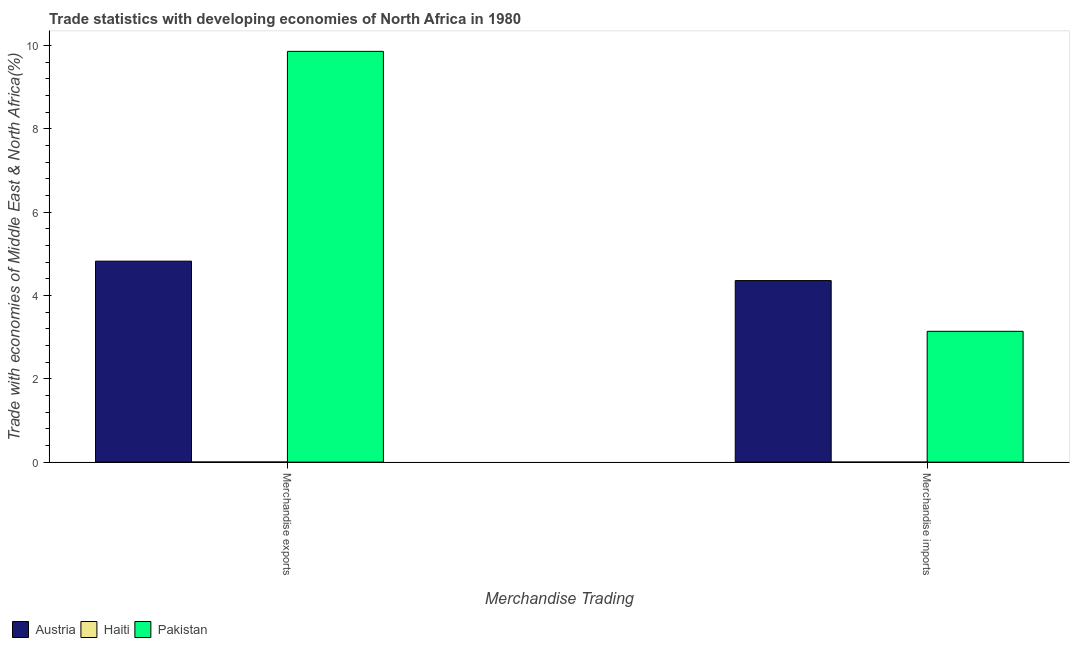Are the number of bars per tick equal to the number of legend labels?
Ensure brevity in your answer.  Yes. Are the number of bars on each tick of the X-axis equal?
Keep it short and to the point. Yes. How many bars are there on the 1st tick from the left?
Your response must be concise. 3. How many bars are there on the 1st tick from the right?
Your answer should be compact. 3. What is the merchandise imports in Austria?
Ensure brevity in your answer.  4.36. Across all countries, what is the maximum merchandise imports?
Offer a very short reply. 4.36. Across all countries, what is the minimum merchandise exports?
Your answer should be very brief. 0. In which country was the merchandise exports minimum?
Give a very brief answer. Haiti. What is the total merchandise imports in the graph?
Provide a short and direct response. 7.5. What is the difference between the merchandise imports in Pakistan and that in Haiti?
Offer a very short reply. 3.14. What is the difference between the merchandise imports in Austria and the merchandise exports in Haiti?
Make the answer very short. 4.36. What is the average merchandise imports per country?
Make the answer very short. 2.5. What is the difference between the merchandise exports and merchandise imports in Austria?
Your answer should be compact. 0.47. In how many countries, is the merchandise exports greater than 3.2 %?
Provide a succinct answer. 2. What is the ratio of the merchandise exports in Pakistan to that in Austria?
Your answer should be very brief. 2.04. In how many countries, is the merchandise exports greater than the average merchandise exports taken over all countries?
Ensure brevity in your answer.  1. What does the 2nd bar from the left in Merchandise imports represents?
Ensure brevity in your answer.  Haiti. Are the values on the major ticks of Y-axis written in scientific E-notation?
Provide a succinct answer. No. What is the title of the graph?
Offer a terse response. Trade statistics with developing economies of North Africa in 1980. What is the label or title of the X-axis?
Give a very brief answer. Merchandise Trading. What is the label or title of the Y-axis?
Provide a succinct answer. Trade with economies of Middle East & North Africa(%). What is the Trade with economies of Middle East & North Africa(%) of Austria in Merchandise exports?
Give a very brief answer. 4.83. What is the Trade with economies of Middle East & North Africa(%) of Haiti in Merchandise exports?
Offer a very short reply. 0. What is the Trade with economies of Middle East & North Africa(%) of Pakistan in Merchandise exports?
Offer a very short reply. 9.86. What is the Trade with economies of Middle East & North Africa(%) in Austria in Merchandise imports?
Make the answer very short. 4.36. What is the Trade with economies of Middle East & North Africa(%) in Haiti in Merchandise imports?
Give a very brief answer. 0. What is the Trade with economies of Middle East & North Africa(%) in Pakistan in Merchandise imports?
Offer a terse response. 3.14. Across all Merchandise Trading, what is the maximum Trade with economies of Middle East & North Africa(%) of Austria?
Provide a short and direct response. 4.83. Across all Merchandise Trading, what is the maximum Trade with economies of Middle East & North Africa(%) of Haiti?
Offer a very short reply. 0. Across all Merchandise Trading, what is the maximum Trade with economies of Middle East & North Africa(%) of Pakistan?
Your answer should be very brief. 9.86. Across all Merchandise Trading, what is the minimum Trade with economies of Middle East & North Africa(%) in Austria?
Your answer should be compact. 4.36. Across all Merchandise Trading, what is the minimum Trade with economies of Middle East & North Africa(%) in Haiti?
Your response must be concise. 0. Across all Merchandise Trading, what is the minimum Trade with economies of Middle East & North Africa(%) in Pakistan?
Offer a very short reply. 3.14. What is the total Trade with economies of Middle East & North Africa(%) in Austria in the graph?
Ensure brevity in your answer.  9.18. What is the total Trade with economies of Middle East & North Africa(%) of Haiti in the graph?
Keep it short and to the point. 0. What is the total Trade with economies of Middle East & North Africa(%) in Pakistan in the graph?
Make the answer very short. 13. What is the difference between the Trade with economies of Middle East & North Africa(%) in Austria in Merchandise exports and that in Merchandise imports?
Offer a terse response. 0.47. What is the difference between the Trade with economies of Middle East & North Africa(%) of Haiti in Merchandise exports and that in Merchandise imports?
Ensure brevity in your answer.  0. What is the difference between the Trade with economies of Middle East & North Africa(%) in Pakistan in Merchandise exports and that in Merchandise imports?
Ensure brevity in your answer.  6.72. What is the difference between the Trade with economies of Middle East & North Africa(%) of Austria in Merchandise exports and the Trade with economies of Middle East & North Africa(%) of Haiti in Merchandise imports?
Ensure brevity in your answer.  4.82. What is the difference between the Trade with economies of Middle East & North Africa(%) of Austria in Merchandise exports and the Trade with economies of Middle East & North Africa(%) of Pakistan in Merchandise imports?
Your answer should be compact. 1.69. What is the difference between the Trade with economies of Middle East & North Africa(%) in Haiti in Merchandise exports and the Trade with economies of Middle East & North Africa(%) in Pakistan in Merchandise imports?
Ensure brevity in your answer.  -3.14. What is the average Trade with economies of Middle East & North Africa(%) of Austria per Merchandise Trading?
Provide a succinct answer. 4.59. What is the average Trade with economies of Middle East & North Africa(%) in Haiti per Merchandise Trading?
Your response must be concise. 0. What is the average Trade with economies of Middle East & North Africa(%) of Pakistan per Merchandise Trading?
Your answer should be compact. 6.5. What is the difference between the Trade with economies of Middle East & North Africa(%) of Austria and Trade with economies of Middle East & North Africa(%) of Haiti in Merchandise exports?
Make the answer very short. 4.82. What is the difference between the Trade with economies of Middle East & North Africa(%) of Austria and Trade with economies of Middle East & North Africa(%) of Pakistan in Merchandise exports?
Provide a succinct answer. -5.04. What is the difference between the Trade with economies of Middle East & North Africa(%) in Haiti and Trade with economies of Middle East & North Africa(%) in Pakistan in Merchandise exports?
Provide a succinct answer. -9.86. What is the difference between the Trade with economies of Middle East & North Africa(%) of Austria and Trade with economies of Middle East & North Africa(%) of Haiti in Merchandise imports?
Offer a very short reply. 4.36. What is the difference between the Trade with economies of Middle East & North Africa(%) of Austria and Trade with economies of Middle East & North Africa(%) of Pakistan in Merchandise imports?
Ensure brevity in your answer.  1.22. What is the difference between the Trade with economies of Middle East & North Africa(%) of Haiti and Trade with economies of Middle East & North Africa(%) of Pakistan in Merchandise imports?
Make the answer very short. -3.14. What is the ratio of the Trade with economies of Middle East & North Africa(%) in Austria in Merchandise exports to that in Merchandise imports?
Provide a short and direct response. 1.11. What is the ratio of the Trade with economies of Middle East & North Africa(%) of Haiti in Merchandise exports to that in Merchandise imports?
Make the answer very short. 4.71. What is the ratio of the Trade with economies of Middle East & North Africa(%) of Pakistan in Merchandise exports to that in Merchandise imports?
Provide a short and direct response. 3.14. What is the difference between the highest and the second highest Trade with economies of Middle East & North Africa(%) of Austria?
Your response must be concise. 0.47. What is the difference between the highest and the second highest Trade with economies of Middle East & North Africa(%) of Haiti?
Provide a short and direct response. 0. What is the difference between the highest and the second highest Trade with economies of Middle East & North Africa(%) in Pakistan?
Your answer should be very brief. 6.72. What is the difference between the highest and the lowest Trade with economies of Middle East & North Africa(%) of Austria?
Make the answer very short. 0.47. What is the difference between the highest and the lowest Trade with economies of Middle East & North Africa(%) in Haiti?
Ensure brevity in your answer.  0. What is the difference between the highest and the lowest Trade with economies of Middle East & North Africa(%) of Pakistan?
Keep it short and to the point. 6.72. 